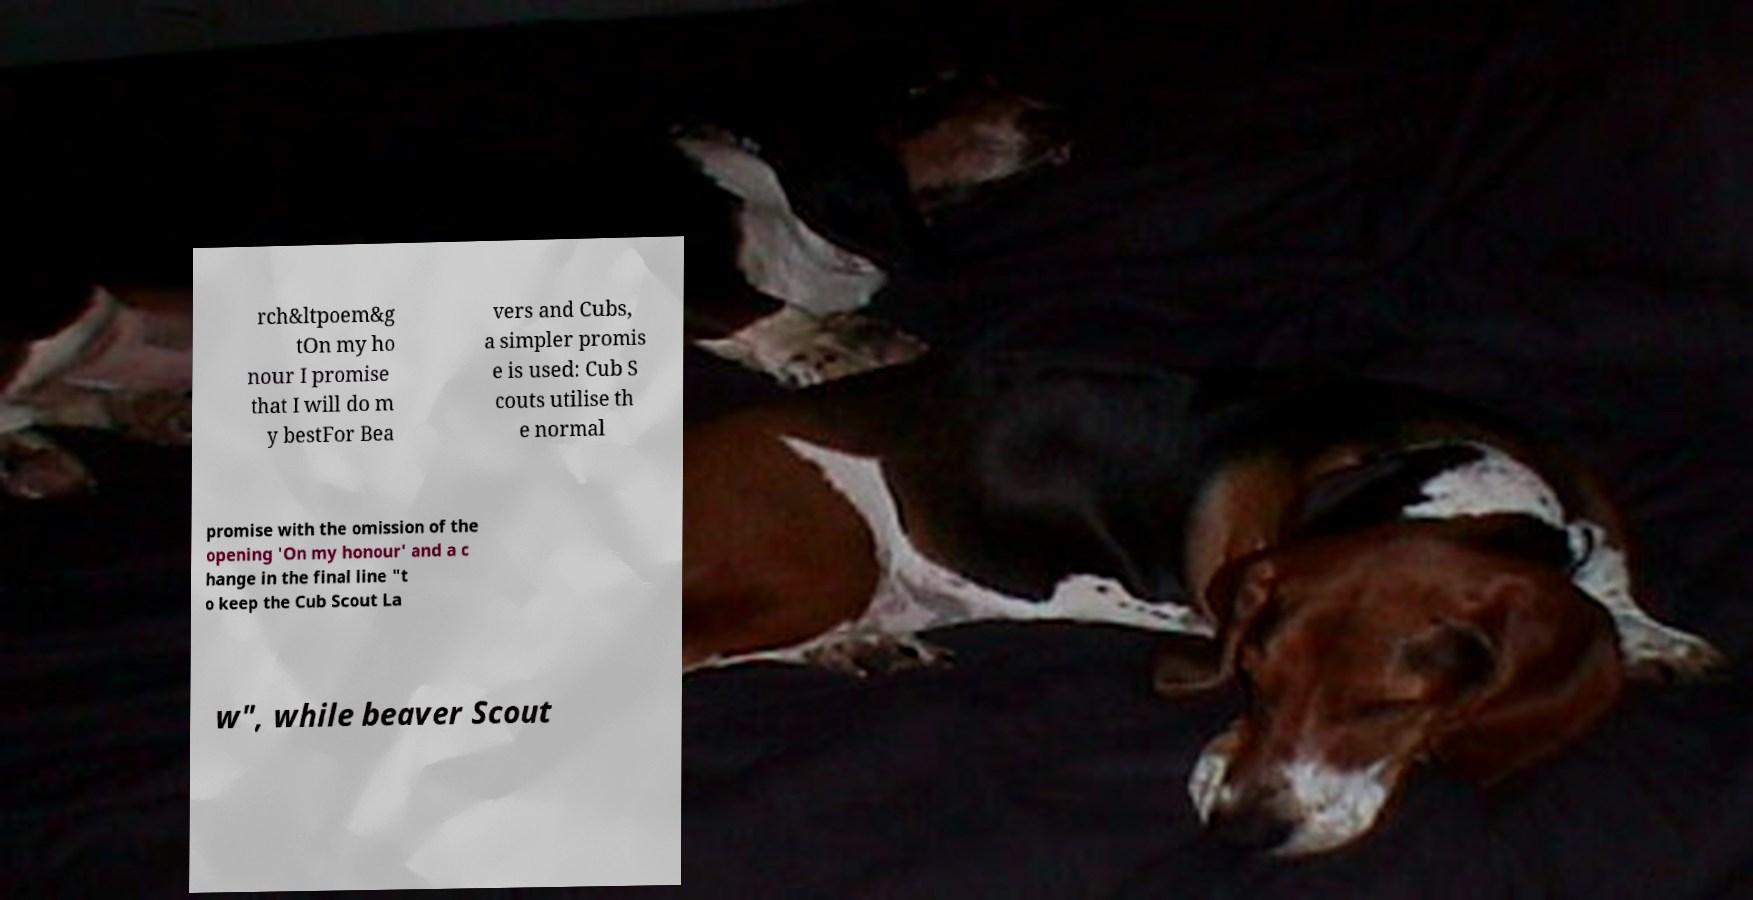Could you extract and type out the text from this image? rch&ltpoem&g tOn my ho nour I promise that I will do m y bestFor Bea vers and Cubs, a simpler promis e is used: Cub S couts utilise th e normal promise with the omission of the opening 'On my honour' and a c hange in the final line "t o keep the Cub Scout La w", while beaver Scout 